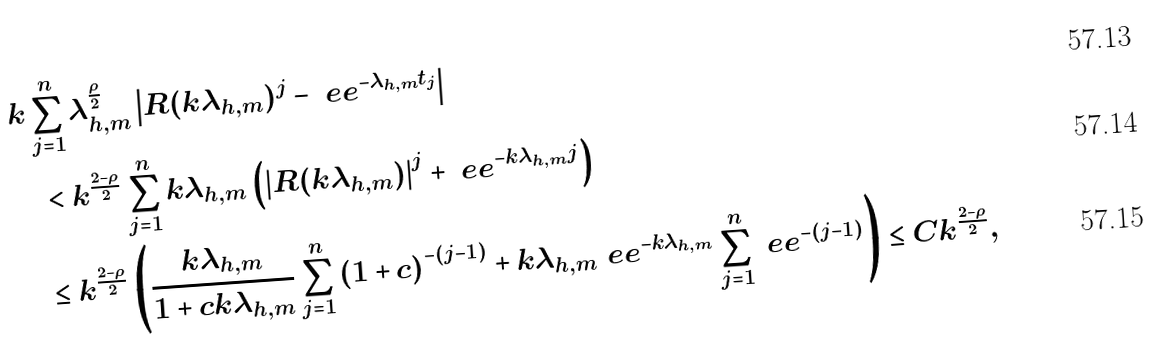Convert formula to latex. <formula><loc_0><loc_0><loc_500><loc_500>& k \sum _ { j = 1 } ^ { n } \lambda _ { h , m } ^ { \frac { \rho } { 2 } } \left | R ( k \lambda _ { h , m } ) ^ { j } - \ e e ^ { - \lambda _ { h , m } t _ { j } } \right | \\ & \quad < k ^ { \frac { 2 - \rho } { 2 } } \sum _ { j = 1 } ^ { n } k \lambda _ { h , m } \left ( \left | R ( k \lambda _ { h , m } ) \right | ^ { j } + \ e e ^ { - k \lambda _ { h , m } j } \right ) \\ & \quad \leq k ^ { \frac { 2 - \rho } { 2 } } \left ( \frac { k \lambda _ { h , m } } { 1 + c k \lambda _ { h , m } } \sum _ { j = 1 } ^ { n } \left ( 1 + c \right ) ^ { - ( j - 1 ) } + k \lambda _ { h , m } \ e e ^ { - k \lambda _ { h , m } } \sum _ { j = 1 } ^ { n } \ e e ^ { - ( j - 1 ) } \right ) \leq C k ^ { \frac { 2 - \rho } { 2 } } ,</formula> 